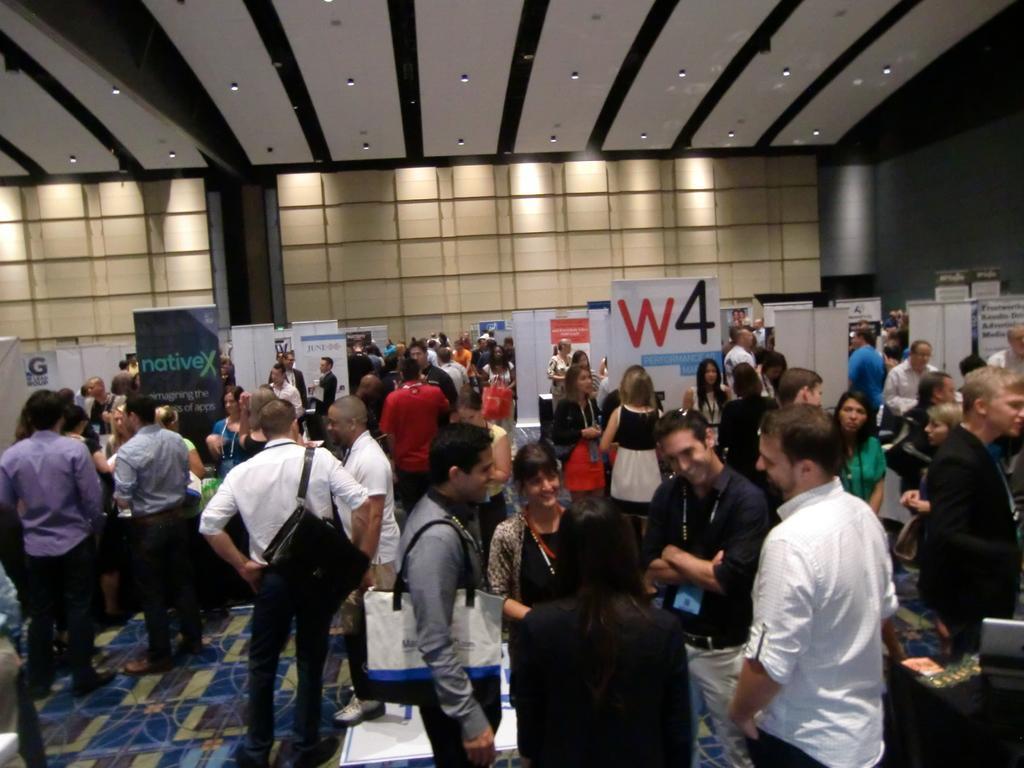How would you summarize this image in a sentence or two? In this image, there are a few people. We can see the ground. We can also see some boards with text written. We can see the wall and the roof with lights. 